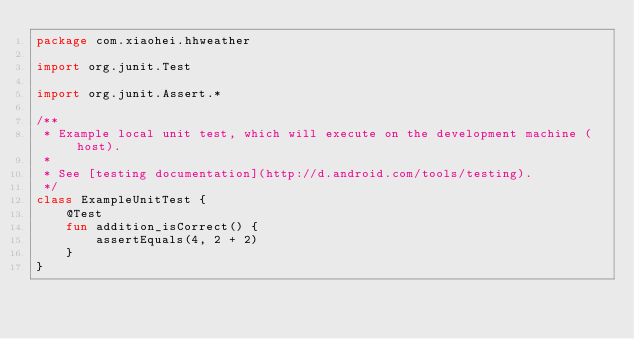<code> <loc_0><loc_0><loc_500><loc_500><_Kotlin_>package com.xiaohei.hhweather

import org.junit.Test

import org.junit.Assert.*

/**
 * Example local unit test, which will execute on the development machine (host).
 *
 * See [testing documentation](http://d.android.com/tools/testing).
 */
class ExampleUnitTest {
    @Test
    fun addition_isCorrect() {
        assertEquals(4, 2 + 2)
    }
}</code> 